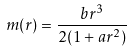<formula> <loc_0><loc_0><loc_500><loc_500>m ( r ) = \frac { b r ^ { 3 } } { 2 ( 1 + a r ^ { 2 } ) }</formula> 